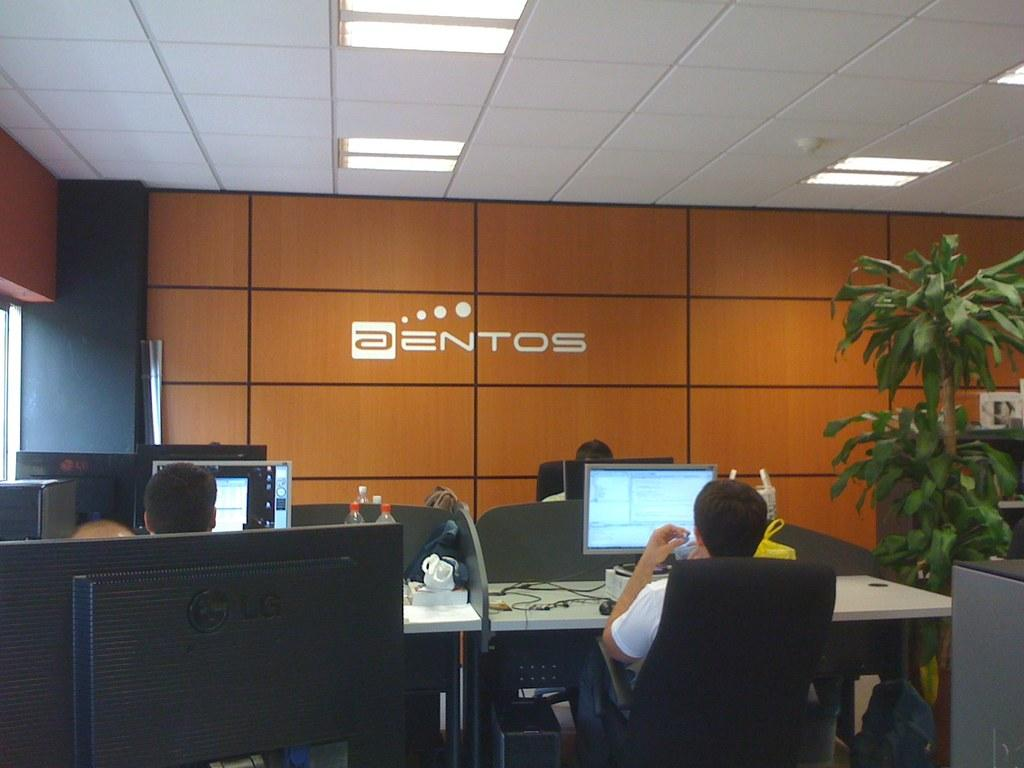<image>
Offer a succinct explanation of the picture presented. A workplace with several stations and aentos on the wall. 